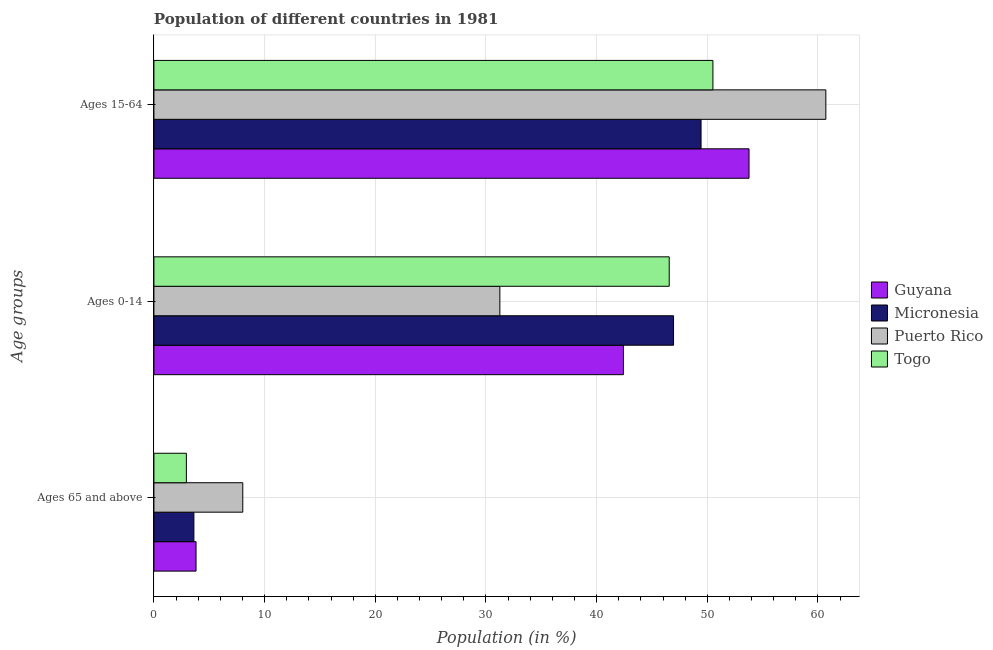How many different coloured bars are there?
Your answer should be compact. 4. Are the number of bars on each tick of the Y-axis equal?
Provide a short and direct response. Yes. How many bars are there on the 1st tick from the top?
Provide a succinct answer. 4. What is the label of the 2nd group of bars from the top?
Keep it short and to the point. Ages 0-14. What is the percentage of population within the age-group of 65 and above in Togo?
Offer a terse response. 2.93. Across all countries, what is the maximum percentage of population within the age-group of 65 and above?
Provide a succinct answer. 8.03. Across all countries, what is the minimum percentage of population within the age-group 0-14?
Provide a succinct answer. 31.26. In which country was the percentage of population within the age-group 15-64 maximum?
Keep it short and to the point. Puerto Rico. In which country was the percentage of population within the age-group 0-14 minimum?
Your answer should be very brief. Puerto Rico. What is the total percentage of population within the age-group 15-64 in the graph?
Your response must be concise. 214.43. What is the difference between the percentage of population within the age-group 0-14 in Togo and that in Micronesia?
Ensure brevity in your answer.  -0.39. What is the difference between the percentage of population within the age-group 15-64 in Guyana and the percentage of population within the age-group 0-14 in Micronesia?
Offer a terse response. 6.82. What is the average percentage of population within the age-group 0-14 per country?
Make the answer very short. 41.8. What is the difference between the percentage of population within the age-group 15-64 and percentage of population within the age-group of 65 and above in Micronesia?
Offer a very short reply. 45.83. What is the ratio of the percentage of population within the age-group 15-64 in Guyana to that in Puerto Rico?
Your answer should be very brief. 0.89. Is the percentage of population within the age-group of 65 and above in Guyana less than that in Puerto Rico?
Your response must be concise. Yes. Is the difference between the percentage of population within the age-group 0-14 in Togo and Micronesia greater than the difference between the percentage of population within the age-group of 65 and above in Togo and Micronesia?
Your answer should be compact. Yes. What is the difference between the highest and the second highest percentage of population within the age-group 15-64?
Provide a succinct answer. 6.94. What is the difference between the highest and the lowest percentage of population within the age-group 15-64?
Make the answer very short. 11.28. What does the 1st bar from the top in Ages 0-14 represents?
Your answer should be very brief. Togo. What does the 4th bar from the bottom in Ages 15-64 represents?
Your response must be concise. Togo. How many bars are there?
Make the answer very short. 12. Are all the bars in the graph horizontal?
Make the answer very short. Yes. How many countries are there in the graph?
Keep it short and to the point. 4. What is the difference between two consecutive major ticks on the X-axis?
Your response must be concise. 10. Are the values on the major ticks of X-axis written in scientific E-notation?
Provide a short and direct response. No. Does the graph contain any zero values?
Make the answer very short. No. Where does the legend appear in the graph?
Make the answer very short. Center right. How many legend labels are there?
Offer a terse response. 4. How are the legend labels stacked?
Ensure brevity in your answer.  Vertical. What is the title of the graph?
Your answer should be compact. Population of different countries in 1981. What is the label or title of the Y-axis?
Make the answer very short. Age groups. What is the Population (in %) in Guyana in Ages 65 and above?
Keep it short and to the point. 3.81. What is the Population (in %) of Micronesia in Ages 65 and above?
Ensure brevity in your answer.  3.61. What is the Population (in %) of Puerto Rico in Ages 65 and above?
Provide a succinct answer. 8.03. What is the Population (in %) of Togo in Ages 65 and above?
Keep it short and to the point. 2.93. What is the Population (in %) in Guyana in Ages 0-14?
Keep it short and to the point. 42.42. What is the Population (in %) of Micronesia in Ages 0-14?
Your answer should be very brief. 46.95. What is the Population (in %) in Puerto Rico in Ages 0-14?
Keep it short and to the point. 31.26. What is the Population (in %) of Togo in Ages 0-14?
Give a very brief answer. 46.56. What is the Population (in %) of Guyana in Ages 15-64?
Offer a very short reply. 53.77. What is the Population (in %) of Micronesia in Ages 15-64?
Provide a short and direct response. 49.44. What is the Population (in %) in Puerto Rico in Ages 15-64?
Provide a succinct answer. 60.71. What is the Population (in %) of Togo in Ages 15-64?
Your answer should be compact. 50.51. Across all Age groups, what is the maximum Population (in %) in Guyana?
Ensure brevity in your answer.  53.77. Across all Age groups, what is the maximum Population (in %) of Micronesia?
Offer a terse response. 49.44. Across all Age groups, what is the maximum Population (in %) of Puerto Rico?
Make the answer very short. 60.71. Across all Age groups, what is the maximum Population (in %) of Togo?
Ensure brevity in your answer.  50.51. Across all Age groups, what is the minimum Population (in %) in Guyana?
Give a very brief answer. 3.81. Across all Age groups, what is the minimum Population (in %) of Micronesia?
Give a very brief answer. 3.61. Across all Age groups, what is the minimum Population (in %) of Puerto Rico?
Your answer should be very brief. 8.03. Across all Age groups, what is the minimum Population (in %) of Togo?
Keep it short and to the point. 2.93. What is the total Population (in %) in Micronesia in the graph?
Offer a very short reply. 100. What is the difference between the Population (in %) of Guyana in Ages 65 and above and that in Ages 0-14?
Make the answer very short. -38.62. What is the difference between the Population (in %) of Micronesia in Ages 65 and above and that in Ages 0-14?
Provide a succinct answer. -43.34. What is the difference between the Population (in %) in Puerto Rico in Ages 65 and above and that in Ages 0-14?
Offer a terse response. -23.23. What is the difference between the Population (in %) in Togo in Ages 65 and above and that in Ages 0-14?
Provide a succinct answer. -43.63. What is the difference between the Population (in %) in Guyana in Ages 65 and above and that in Ages 15-64?
Provide a succinct answer. -49.97. What is the difference between the Population (in %) in Micronesia in Ages 65 and above and that in Ages 15-64?
Your answer should be compact. -45.83. What is the difference between the Population (in %) of Puerto Rico in Ages 65 and above and that in Ages 15-64?
Give a very brief answer. -52.68. What is the difference between the Population (in %) in Togo in Ages 65 and above and that in Ages 15-64?
Offer a very short reply. -47.58. What is the difference between the Population (in %) of Guyana in Ages 0-14 and that in Ages 15-64?
Provide a succinct answer. -11.35. What is the difference between the Population (in %) in Micronesia in Ages 0-14 and that in Ages 15-64?
Make the answer very short. -2.49. What is the difference between the Population (in %) in Puerto Rico in Ages 0-14 and that in Ages 15-64?
Offer a terse response. -29.45. What is the difference between the Population (in %) of Togo in Ages 0-14 and that in Ages 15-64?
Give a very brief answer. -3.95. What is the difference between the Population (in %) in Guyana in Ages 65 and above and the Population (in %) in Micronesia in Ages 0-14?
Keep it short and to the point. -43.14. What is the difference between the Population (in %) in Guyana in Ages 65 and above and the Population (in %) in Puerto Rico in Ages 0-14?
Your response must be concise. -27.45. What is the difference between the Population (in %) in Guyana in Ages 65 and above and the Population (in %) in Togo in Ages 0-14?
Your answer should be compact. -42.75. What is the difference between the Population (in %) in Micronesia in Ages 65 and above and the Population (in %) in Puerto Rico in Ages 0-14?
Offer a very short reply. -27.65. What is the difference between the Population (in %) of Micronesia in Ages 65 and above and the Population (in %) of Togo in Ages 0-14?
Offer a very short reply. -42.95. What is the difference between the Population (in %) of Puerto Rico in Ages 65 and above and the Population (in %) of Togo in Ages 0-14?
Your answer should be compact. -38.53. What is the difference between the Population (in %) of Guyana in Ages 65 and above and the Population (in %) of Micronesia in Ages 15-64?
Give a very brief answer. -45.63. What is the difference between the Population (in %) of Guyana in Ages 65 and above and the Population (in %) of Puerto Rico in Ages 15-64?
Your response must be concise. -56.91. What is the difference between the Population (in %) of Guyana in Ages 65 and above and the Population (in %) of Togo in Ages 15-64?
Provide a succinct answer. -46.7. What is the difference between the Population (in %) in Micronesia in Ages 65 and above and the Population (in %) in Puerto Rico in Ages 15-64?
Provide a succinct answer. -57.1. What is the difference between the Population (in %) in Micronesia in Ages 65 and above and the Population (in %) in Togo in Ages 15-64?
Ensure brevity in your answer.  -46.9. What is the difference between the Population (in %) in Puerto Rico in Ages 65 and above and the Population (in %) in Togo in Ages 15-64?
Give a very brief answer. -42.48. What is the difference between the Population (in %) of Guyana in Ages 0-14 and the Population (in %) of Micronesia in Ages 15-64?
Your answer should be very brief. -7.02. What is the difference between the Population (in %) of Guyana in Ages 0-14 and the Population (in %) of Puerto Rico in Ages 15-64?
Your answer should be very brief. -18.29. What is the difference between the Population (in %) in Guyana in Ages 0-14 and the Population (in %) in Togo in Ages 15-64?
Your answer should be very brief. -8.09. What is the difference between the Population (in %) of Micronesia in Ages 0-14 and the Population (in %) of Puerto Rico in Ages 15-64?
Make the answer very short. -13.76. What is the difference between the Population (in %) of Micronesia in Ages 0-14 and the Population (in %) of Togo in Ages 15-64?
Ensure brevity in your answer.  -3.56. What is the difference between the Population (in %) of Puerto Rico in Ages 0-14 and the Population (in %) of Togo in Ages 15-64?
Provide a short and direct response. -19.25. What is the average Population (in %) of Guyana per Age groups?
Provide a short and direct response. 33.33. What is the average Population (in %) of Micronesia per Age groups?
Provide a succinct answer. 33.33. What is the average Population (in %) in Puerto Rico per Age groups?
Offer a terse response. 33.33. What is the average Population (in %) in Togo per Age groups?
Offer a very short reply. 33.33. What is the difference between the Population (in %) in Guyana and Population (in %) in Micronesia in Ages 65 and above?
Offer a terse response. 0.2. What is the difference between the Population (in %) in Guyana and Population (in %) in Puerto Rico in Ages 65 and above?
Offer a very short reply. -4.22. What is the difference between the Population (in %) in Guyana and Population (in %) in Togo in Ages 65 and above?
Make the answer very short. 0.87. What is the difference between the Population (in %) in Micronesia and Population (in %) in Puerto Rico in Ages 65 and above?
Give a very brief answer. -4.42. What is the difference between the Population (in %) of Micronesia and Population (in %) of Togo in Ages 65 and above?
Keep it short and to the point. 0.68. What is the difference between the Population (in %) of Puerto Rico and Population (in %) of Togo in Ages 65 and above?
Keep it short and to the point. 5.1. What is the difference between the Population (in %) of Guyana and Population (in %) of Micronesia in Ages 0-14?
Your answer should be very brief. -4.53. What is the difference between the Population (in %) in Guyana and Population (in %) in Puerto Rico in Ages 0-14?
Keep it short and to the point. 11.16. What is the difference between the Population (in %) of Guyana and Population (in %) of Togo in Ages 0-14?
Your answer should be very brief. -4.14. What is the difference between the Population (in %) of Micronesia and Population (in %) of Puerto Rico in Ages 0-14?
Make the answer very short. 15.69. What is the difference between the Population (in %) of Micronesia and Population (in %) of Togo in Ages 0-14?
Give a very brief answer. 0.39. What is the difference between the Population (in %) in Puerto Rico and Population (in %) in Togo in Ages 0-14?
Keep it short and to the point. -15.3. What is the difference between the Population (in %) in Guyana and Population (in %) in Micronesia in Ages 15-64?
Ensure brevity in your answer.  4.33. What is the difference between the Population (in %) of Guyana and Population (in %) of Puerto Rico in Ages 15-64?
Provide a short and direct response. -6.94. What is the difference between the Population (in %) in Guyana and Population (in %) in Togo in Ages 15-64?
Make the answer very short. 3.26. What is the difference between the Population (in %) in Micronesia and Population (in %) in Puerto Rico in Ages 15-64?
Make the answer very short. -11.28. What is the difference between the Population (in %) of Micronesia and Population (in %) of Togo in Ages 15-64?
Provide a succinct answer. -1.07. What is the difference between the Population (in %) of Puerto Rico and Population (in %) of Togo in Ages 15-64?
Make the answer very short. 10.21. What is the ratio of the Population (in %) in Guyana in Ages 65 and above to that in Ages 0-14?
Provide a succinct answer. 0.09. What is the ratio of the Population (in %) of Micronesia in Ages 65 and above to that in Ages 0-14?
Ensure brevity in your answer.  0.08. What is the ratio of the Population (in %) of Puerto Rico in Ages 65 and above to that in Ages 0-14?
Your answer should be compact. 0.26. What is the ratio of the Population (in %) of Togo in Ages 65 and above to that in Ages 0-14?
Keep it short and to the point. 0.06. What is the ratio of the Population (in %) of Guyana in Ages 65 and above to that in Ages 15-64?
Your answer should be very brief. 0.07. What is the ratio of the Population (in %) in Micronesia in Ages 65 and above to that in Ages 15-64?
Offer a very short reply. 0.07. What is the ratio of the Population (in %) in Puerto Rico in Ages 65 and above to that in Ages 15-64?
Provide a short and direct response. 0.13. What is the ratio of the Population (in %) in Togo in Ages 65 and above to that in Ages 15-64?
Your answer should be compact. 0.06. What is the ratio of the Population (in %) of Guyana in Ages 0-14 to that in Ages 15-64?
Provide a short and direct response. 0.79. What is the ratio of the Population (in %) of Micronesia in Ages 0-14 to that in Ages 15-64?
Ensure brevity in your answer.  0.95. What is the ratio of the Population (in %) of Puerto Rico in Ages 0-14 to that in Ages 15-64?
Offer a very short reply. 0.51. What is the ratio of the Population (in %) of Togo in Ages 0-14 to that in Ages 15-64?
Provide a short and direct response. 0.92. What is the difference between the highest and the second highest Population (in %) of Guyana?
Your response must be concise. 11.35. What is the difference between the highest and the second highest Population (in %) of Micronesia?
Provide a succinct answer. 2.49. What is the difference between the highest and the second highest Population (in %) in Puerto Rico?
Give a very brief answer. 29.45. What is the difference between the highest and the second highest Population (in %) in Togo?
Ensure brevity in your answer.  3.95. What is the difference between the highest and the lowest Population (in %) in Guyana?
Your response must be concise. 49.97. What is the difference between the highest and the lowest Population (in %) of Micronesia?
Provide a short and direct response. 45.83. What is the difference between the highest and the lowest Population (in %) of Puerto Rico?
Ensure brevity in your answer.  52.68. What is the difference between the highest and the lowest Population (in %) of Togo?
Your answer should be very brief. 47.58. 